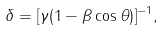Convert formula to latex. <formula><loc_0><loc_0><loc_500><loc_500>\delta = [ \gamma ( 1 - \beta \cos \theta ) ] ^ { - 1 } ,</formula> 